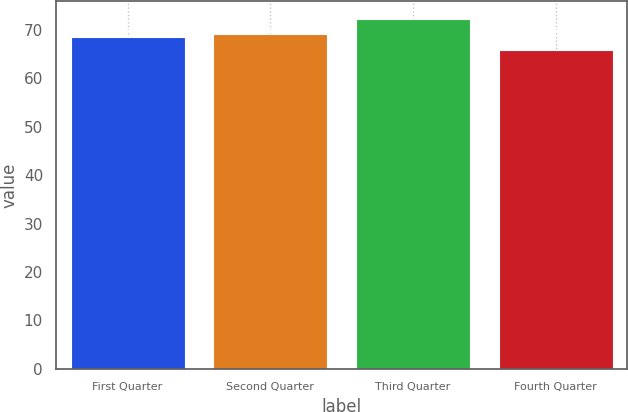<chart> <loc_0><loc_0><loc_500><loc_500><bar_chart><fcel>First Quarter<fcel>Second Quarter<fcel>Third Quarter<fcel>Fourth Quarter<nl><fcel>68.58<fcel>69.22<fcel>72.27<fcel>65.91<nl></chart> 